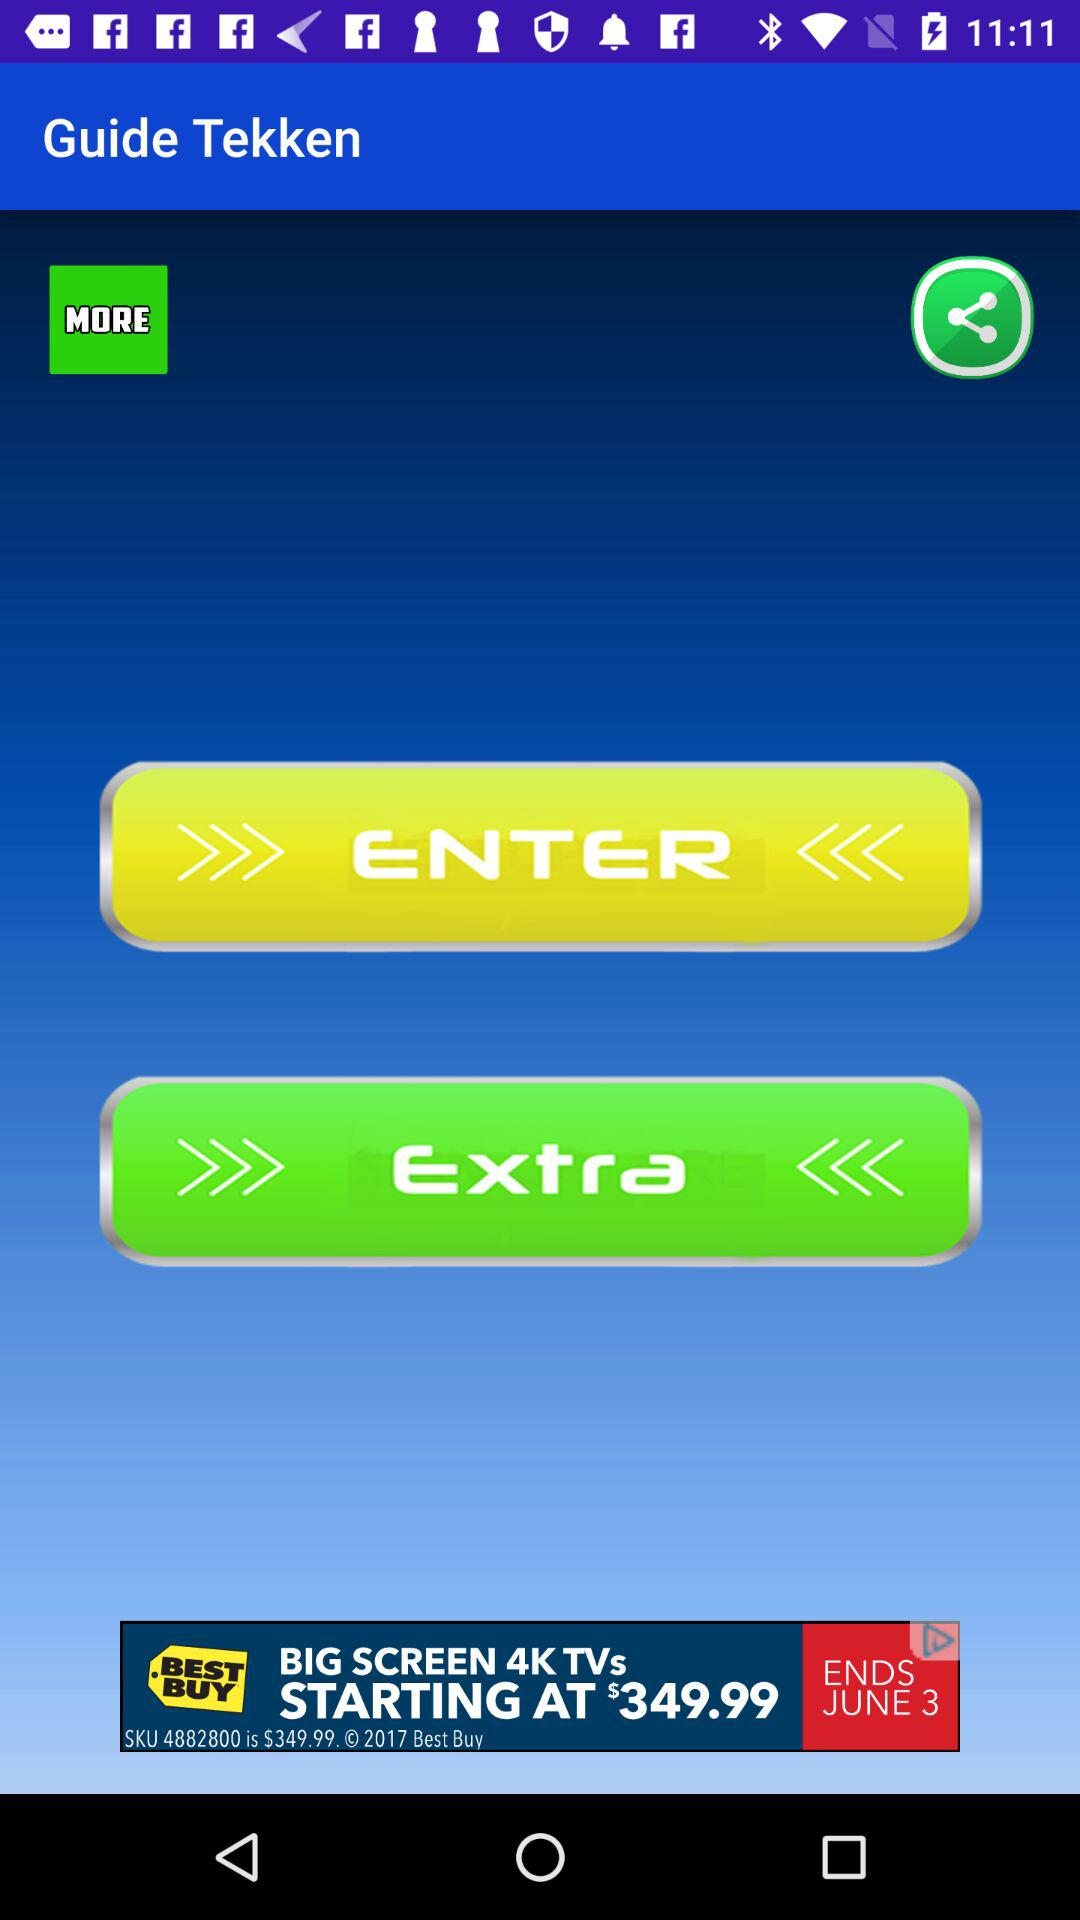What is the app name? The app name is "Guide Tekken". 